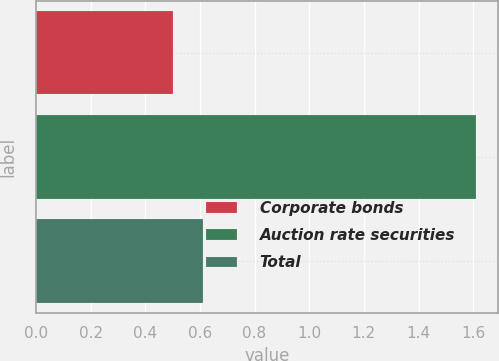Convert chart to OTSL. <chart><loc_0><loc_0><loc_500><loc_500><bar_chart><fcel>Corporate bonds<fcel>Auction rate securities<fcel>Total<nl><fcel>0.5<fcel>1.61<fcel>0.61<nl></chart> 